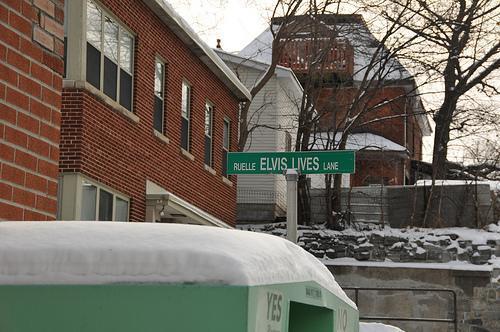How many street signs are there?
Give a very brief answer. 1. 